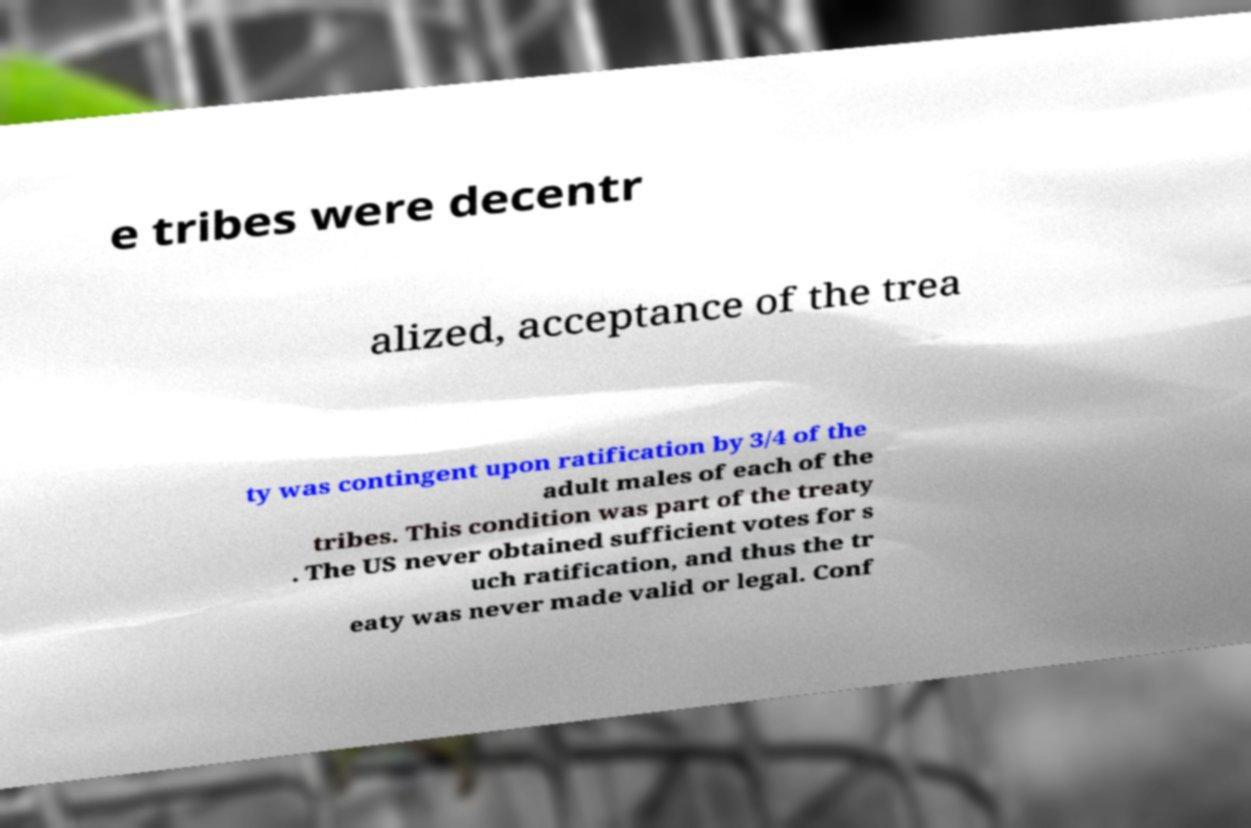Please read and relay the text visible in this image. What does it say? e tribes were decentr alized, acceptance of the trea ty was contingent upon ratification by 3/4 of the adult males of each of the tribes. This condition was part of the treaty . The US never obtained sufficient votes for s uch ratification, and thus the tr eaty was never made valid or legal. Conf 